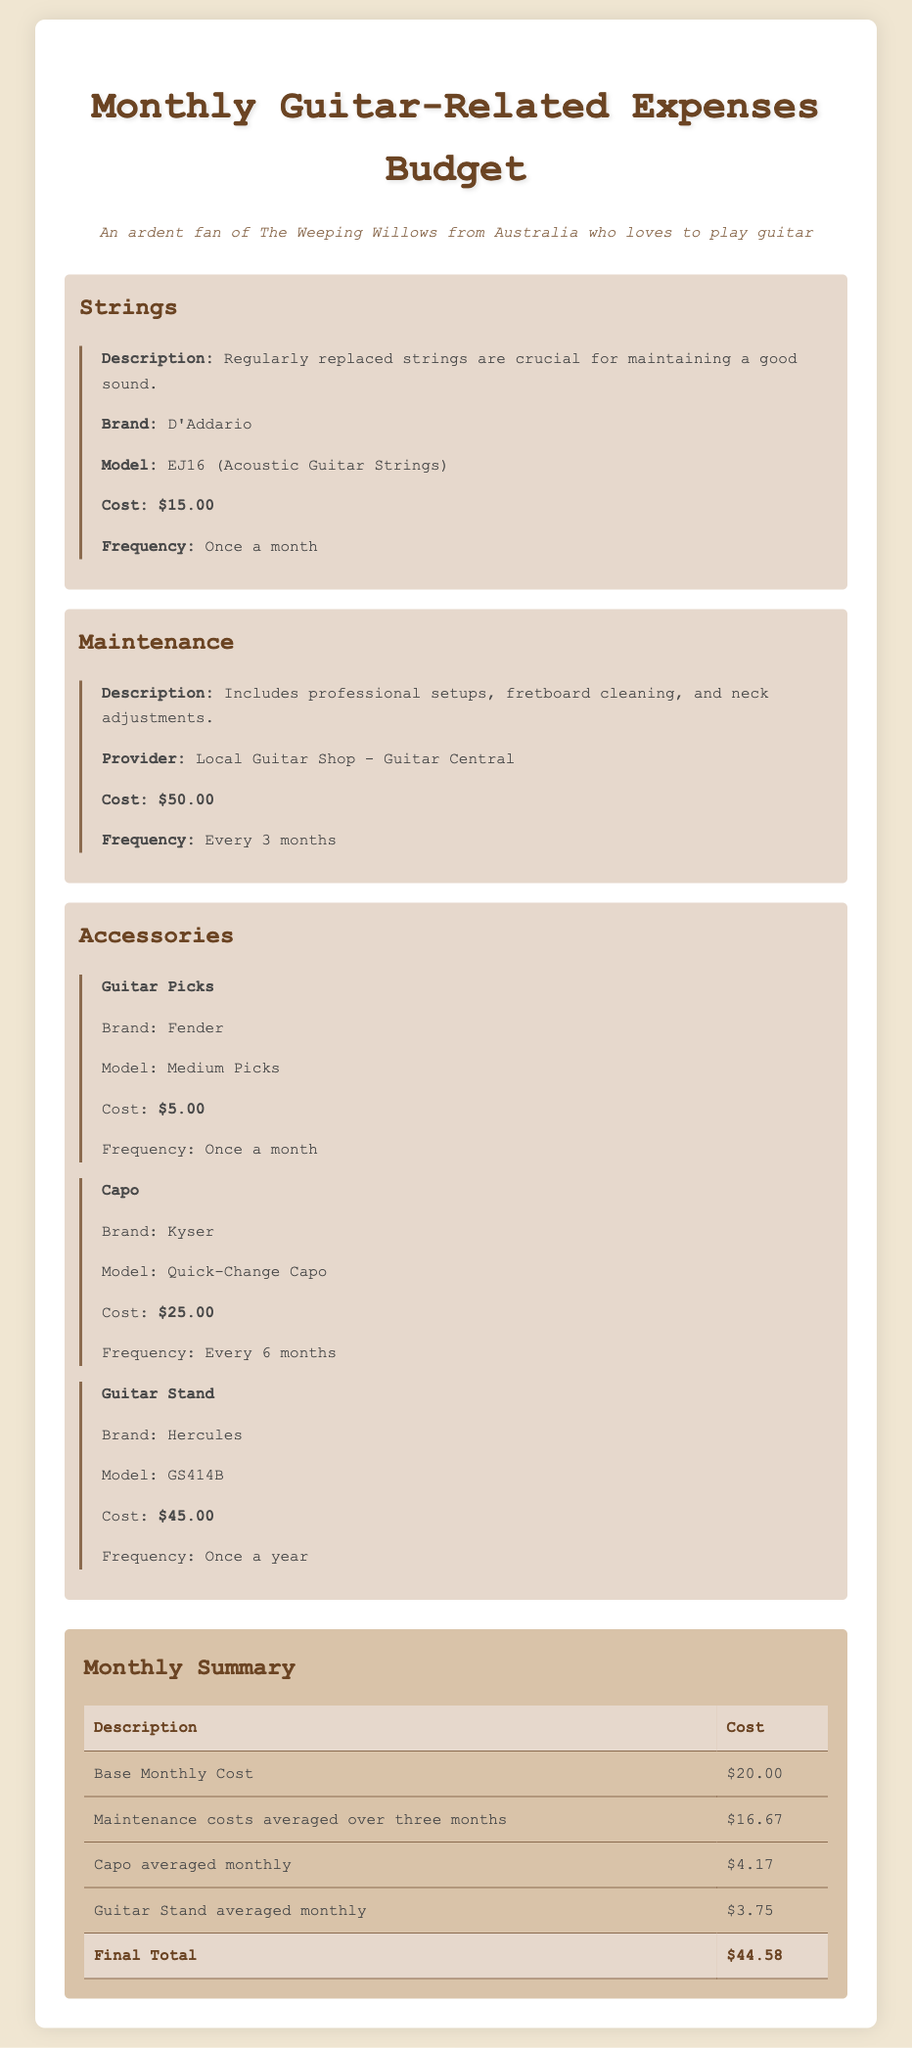What is the brand of the guitar strings? The document states that the guitar strings are from the brand D'Addario.
Answer: D'Addario How much do guitar picks cost? The document lists the cost of guitar picks as $5.00.
Answer: $5.00 How often should strings be replaced? According to the document, strings should be replaced once a month.
Answer: Once a month What is the average monthly cost of maintenance? The average monthly maintenance cost is calculated as $50.00 divided by 3, resulting in $16.67.
Answer: $16.67 What model is the Capo? The Capo is described as a Kyser Quick-Change Capo in the document.
Answer: Quick-Change Capo What is the final total of monthly expenses? The final total of monthly expenses is clearly stated in the summary as $44.58.
Answer: $44.58 How often is the guitar stand averaged out? The document indicates that the guitar stand is averaged once a year, which results in the monthly averaging.
Answer: Once a year What is the brand of the maintenance provider? The document mentions that the maintenance provider is Guitar Central.
Answer: Guitar Central How much does the guitar stand cost? The cost of the guitar stand is listed as $45.00 in the document.
Answer: $45.00 